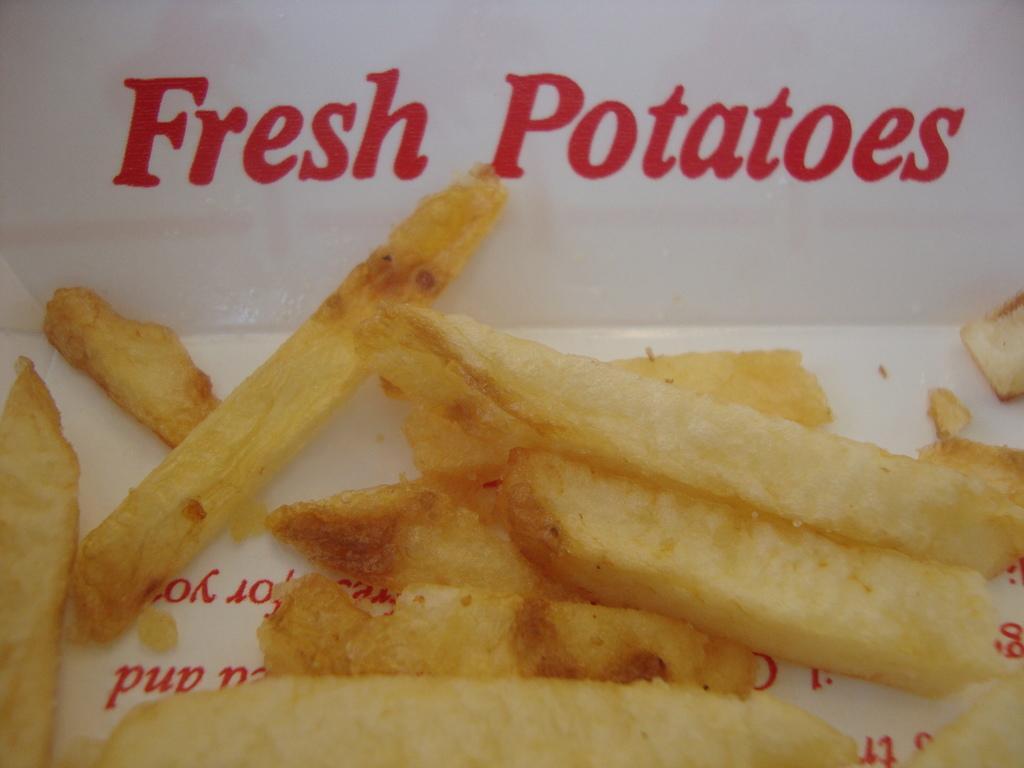How would you summarize this image in a sentence or two? In the picture I can see food items. I can also see something written on a white color object. 